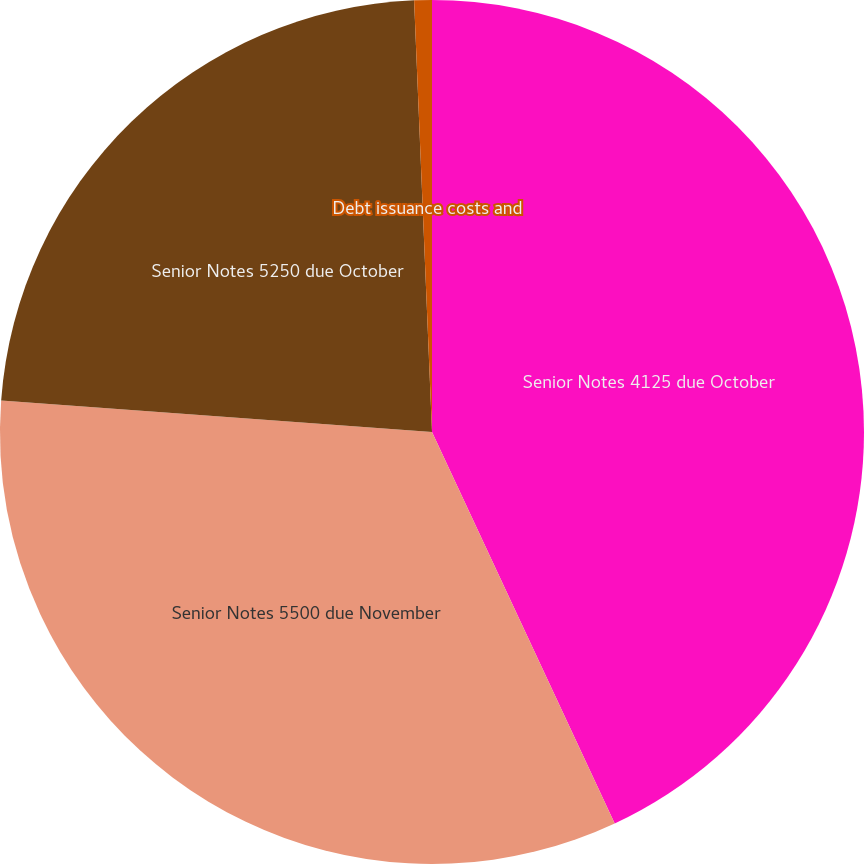Convert chart to OTSL. <chart><loc_0><loc_0><loc_500><loc_500><pie_chart><fcel>Senior Notes 4125 due October<fcel>Senior Notes 5500 due November<fcel>Senior Notes 5250 due October<fcel>Debt issuance costs and<nl><fcel>43.05%<fcel>33.11%<fcel>23.18%<fcel>0.66%<nl></chart> 